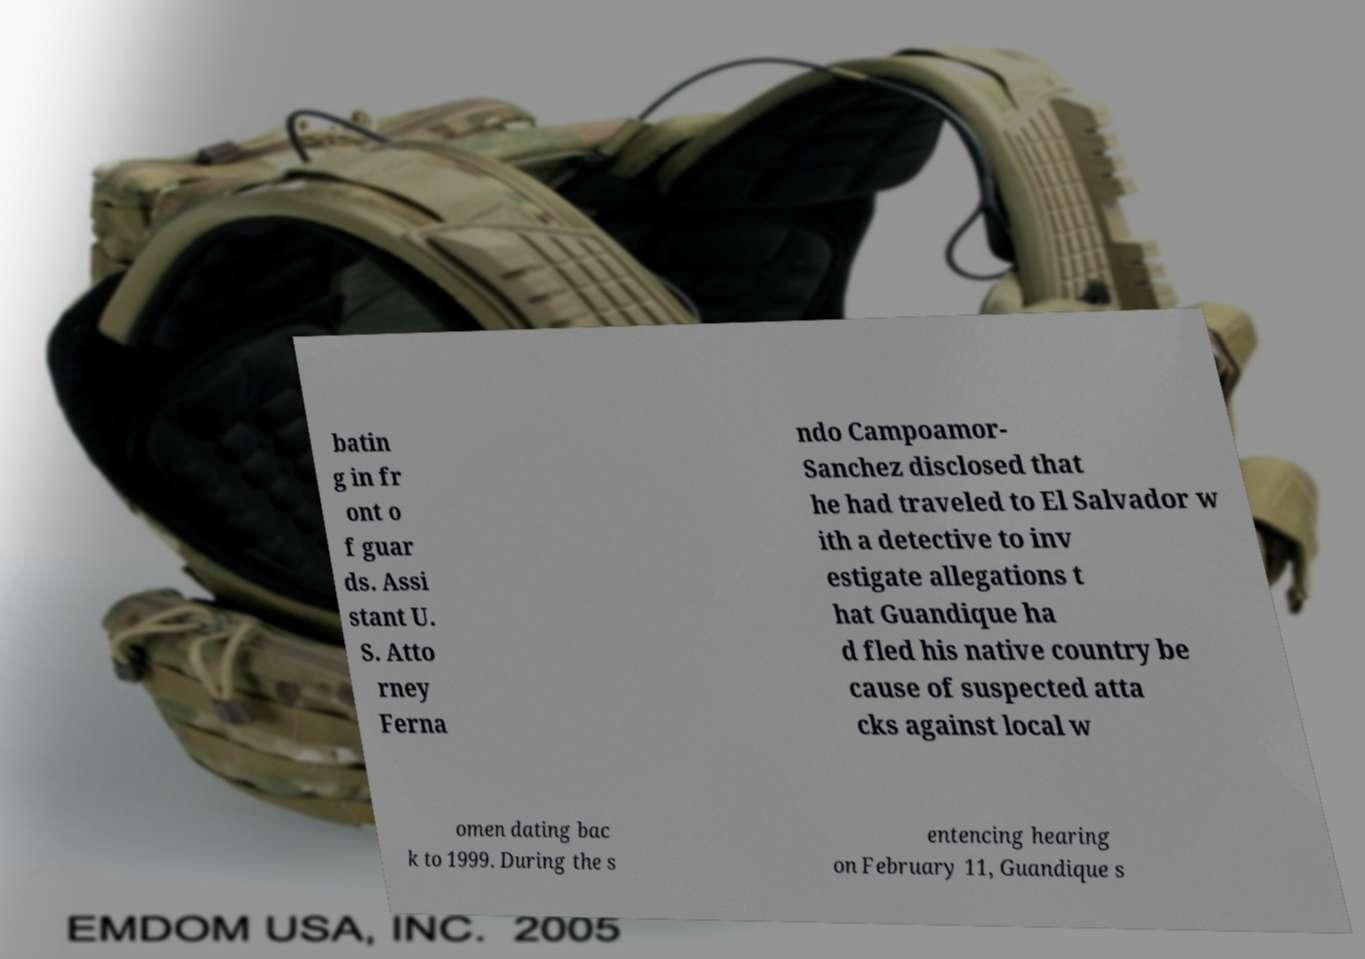Can you accurately transcribe the text from the provided image for me? batin g in fr ont o f guar ds. Assi stant U. S. Atto rney Ferna ndo Campoamor- Sanchez disclosed that he had traveled to El Salvador w ith a detective to inv estigate allegations t hat Guandique ha d fled his native country be cause of suspected atta cks against local w omen dating bac k to 1999. During the s entencing hearing on February 11, Guandique s 